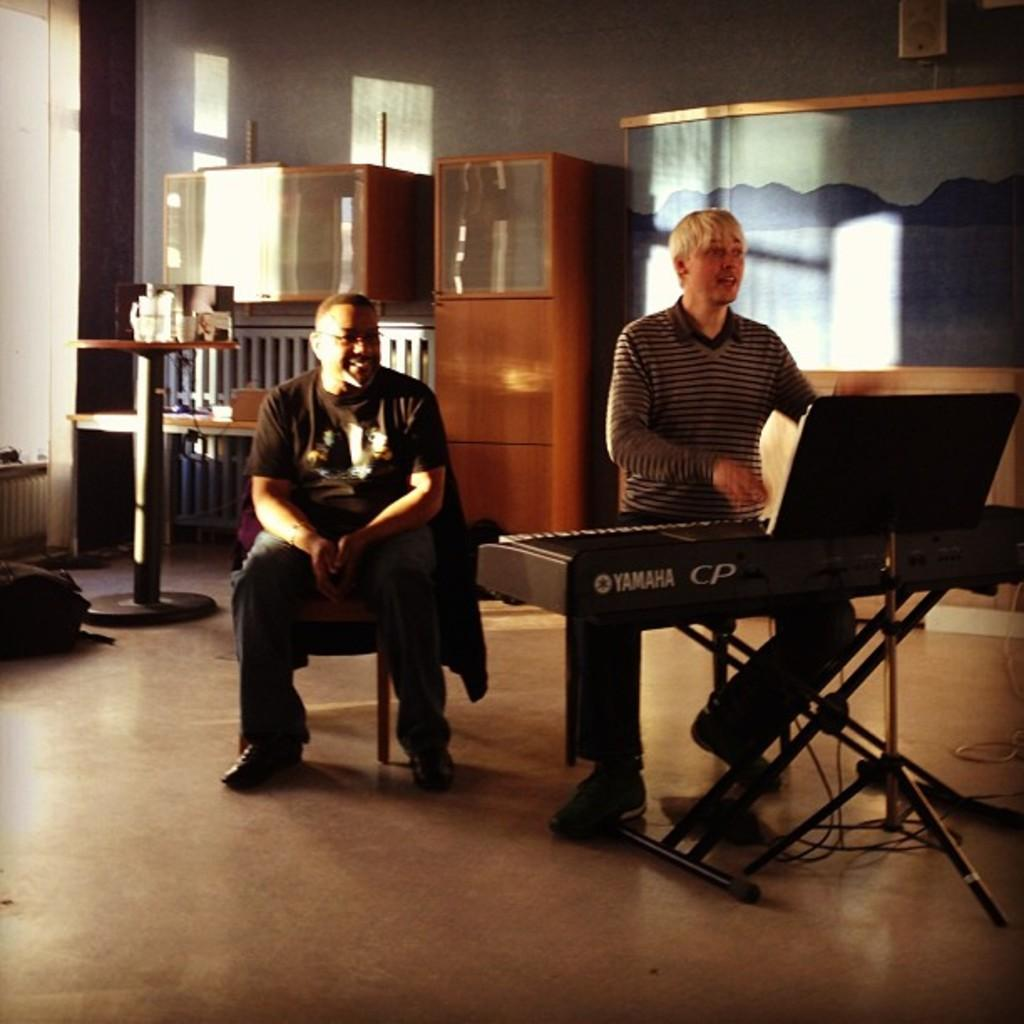What is the person in the image doing? The person is playing the keyboard and singing. Can you describe the position of the other person in the image? The other person is sitting on a stool. What can be seen in the background of the image? There are cupboards, a wall, and a table in the background. Is there any time-related object visible in the image? Yes, there is a clock on the wall. What type of vegetable is being chopped on the table in the image? There is no vegetable or chopping activity visible in the image. Can you tell me the brand of the notebook the person is using while playing the keyboard? There is no notebook present in the image. 